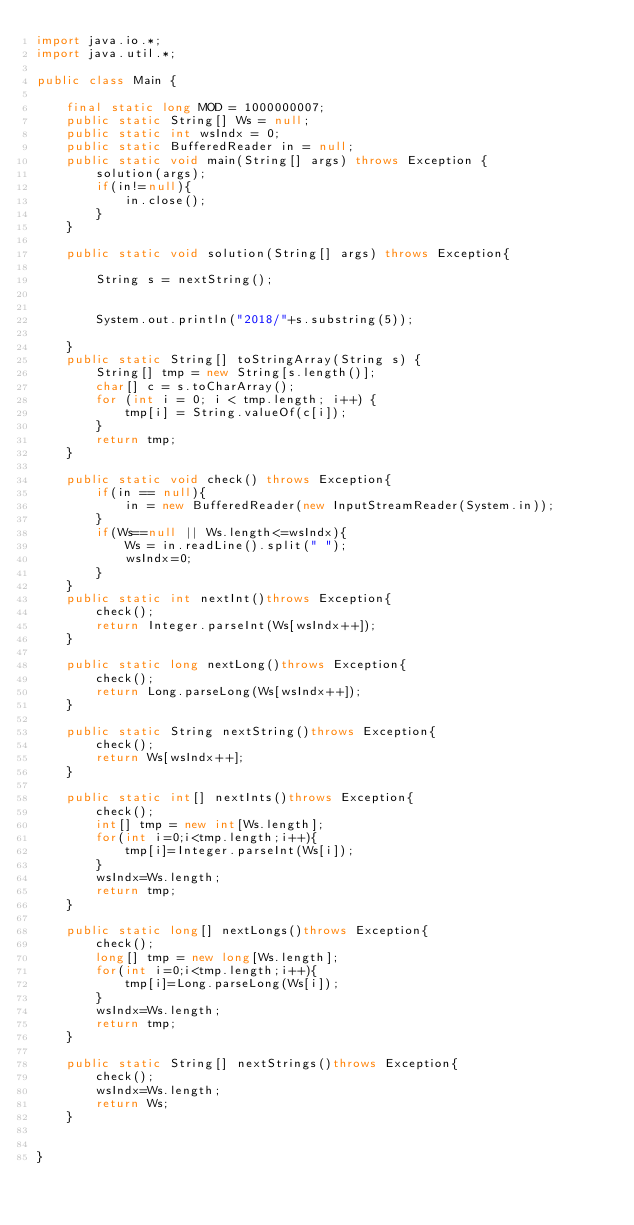<code> <loc_0><loc_0><loc_500><loc_500><_Java_>import java.io.*;
import java.util.*;

public class Main {

	final static long MOD = 1000000007;
	public static String[] Ws = null;
	public static int wsIndx = 0;
	public static BufferedReader in = null;
	public static void main(String[] args) throws Exception {
		solution(args);
		if(in!=null){
			in.close();
		}
	}

	public static void solution(String[] args) throws Exception{

		String s = nextString();


		System.out.println("2018/"+s.substring(5));

	}
	public static String[] toStringArray(String s) {
		String[] tmp = new String[s.length()];
		char[] c = s.toCharArray();
		for (int i = 0; i < tmp.length; i++) {
			tmp[i] = String.valueOf(c[i]);
		}
		return tmp;
	}

	public static void check() throws Exception{
		if(in == null){
			in = new BufferedReader(new InputStreamReader(System.in));
		}
		if(Ws==null || Ws.length<=wsIndx){
			Ws = in.readLine().split(" ");
			wsIndx=0;
		}
	}
	public static int nextInt()throws Exception{
		check();
		return Integer.parseInt(Ws[wsIndx++]);
	}

	public static long nextLong()throws Exception{
		check();
		return Long.parseLong(Ws[wsIndx++]);
	}

	public static String nextString()throws Exception{
		check();
		return Ws[wsIndx++];
	}

	public static int[] nextInts()throws Exception{
		check();
		int[] tmp = new int[Ws.length];
		for(int i=0;i<tmp.length;i++){
			tmp[i]=Integer.parseInt(Ws[i]);
		}
		wsIndx=Ws.length;
		return tmp;
	}

	public static long[] nextLongs()throws Exception{
		check();
		long[] tmp = new long[Ws.length];
		for(int i=0;i<tmp.length;i++){
			tmp[i]=Long.parseLong(Ws[i]);
		}
		wsIndx=Ws.length;
		return tmp;
	}

	public static String[] nextStrings()throws Exception{
		check();
		wsIndx=Ws.length;
		return Ws;
	}


}
</code> 